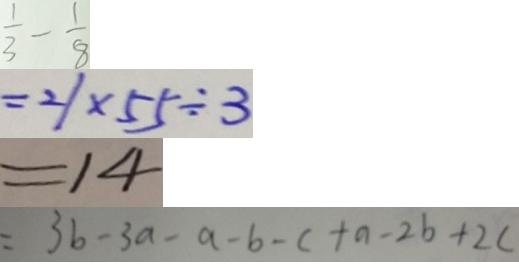Convert formula to latex. <formula><loc_0><loc_0><loc_500><loc_500>= \frac { 1 } { 3 } - \frac { 1 } { 8 } 
 = 2 1 \times 5 5 \div 3 
 = 1 4 
 = 3 b - 3 a - a - b - c + a - 2 b + 2 c</formula> 